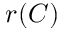Convert formula to latex. <formula><loc_0><loc_0><loc_500><loc_500>r ( C )</formula> 